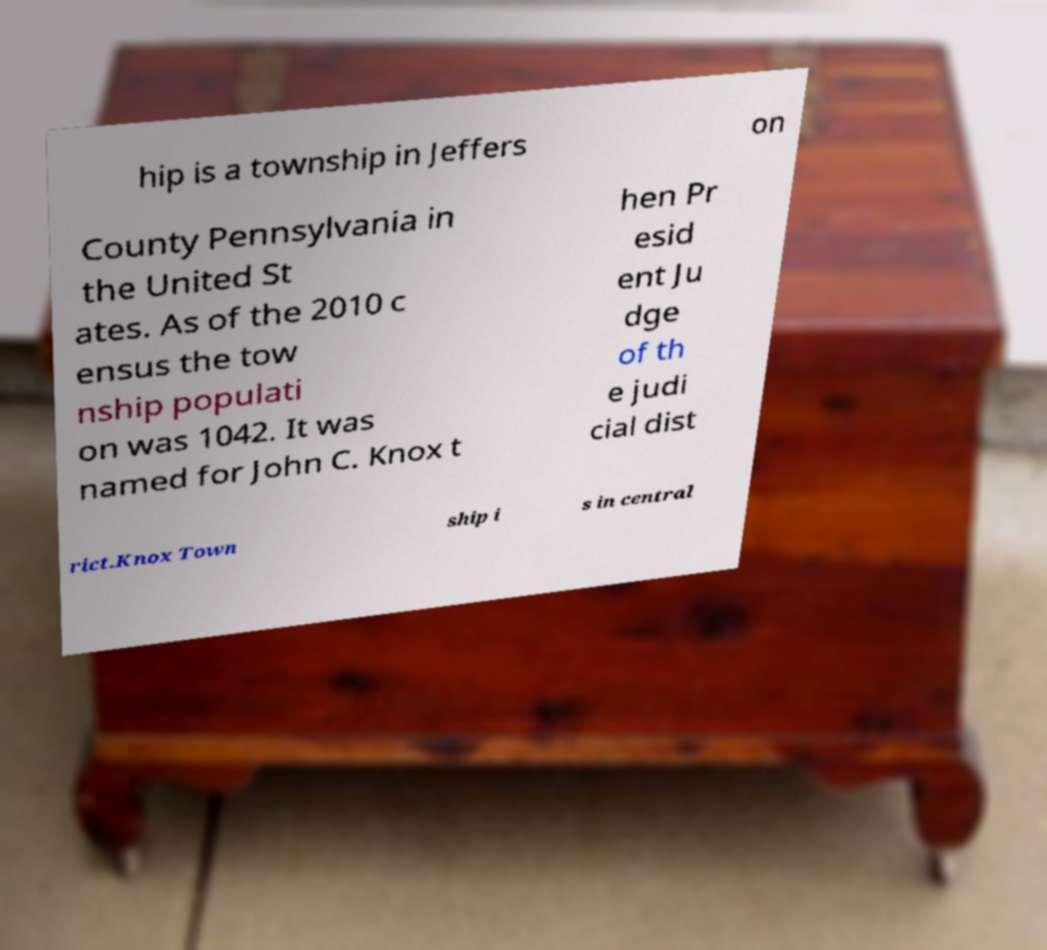Please identify and transcribe the text found in this image. hip is a township in Jeffers on County Pennsylvania in the United St ates. As of the 2010 c ensus the tow nship populati on was 1042. It was named for John C. Knox t hen Pr esid ent Ju dge of th e judi cial dist rict.Knox Town ship i s in central 